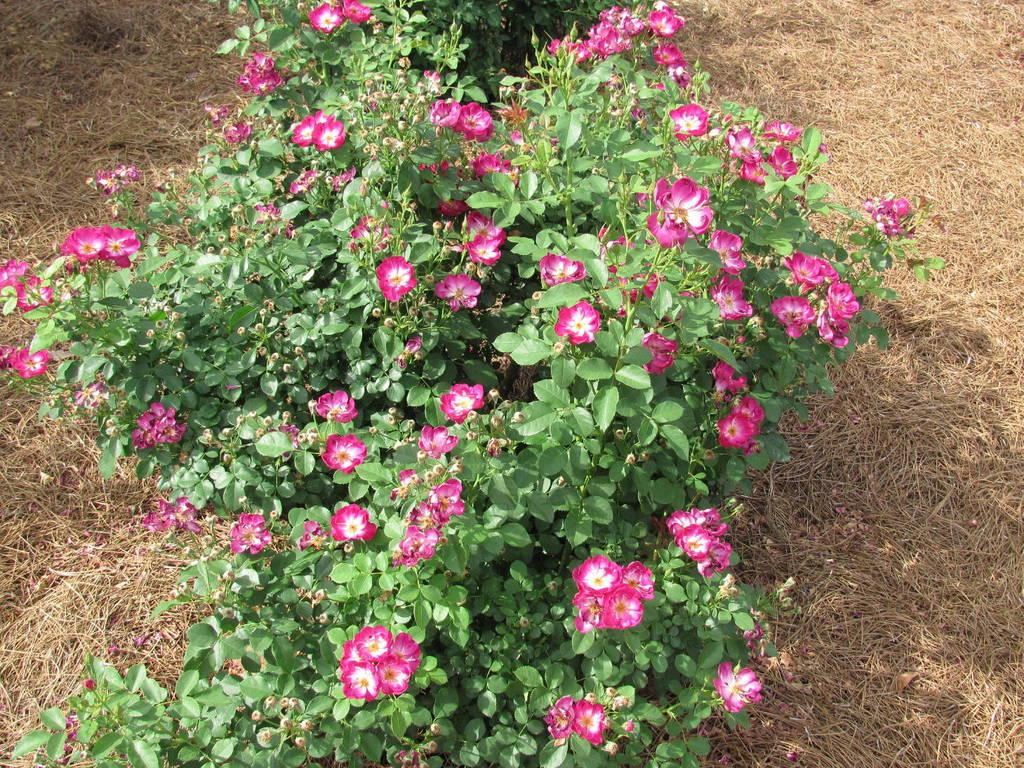What type of plants are in the image? The image contains garden roses plants. What is the flooring made of in the image? There is dried grass floor on both the right and left sides of the image. What type of store can be seen in the background of the image? There is no store present in the image; it features garden roses plants and dried grass flooring. Can you tell me how many people are in the group standing near the garden roses? There is no group of people present in the image; it only shows garden roses plants and dried grass flooring. 